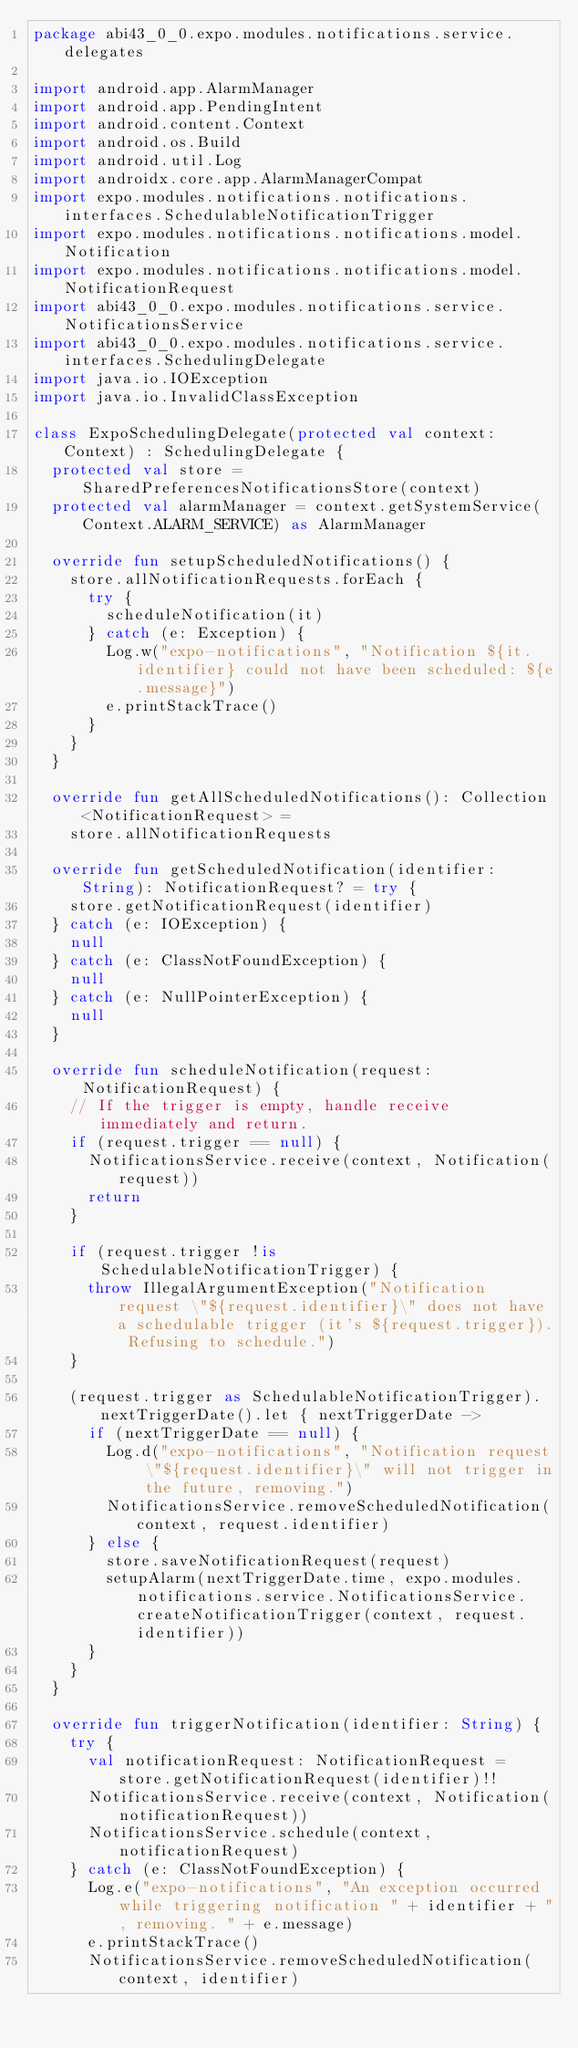<code> <loc_0><loc_0><loc_500><loc_500><_Kotlin_>package abi43_0_0.expo.modules.notifications.service.delegates

import android.app.AlarmManager
import android.app.PendingIntent
import android.content.Context
import android.os.Build
import android.util.Log
import androidx.core.app.AlarmManagerCompat
import expo.modules.notifications.notifications.interfaces.SchedulableNotificationTrigger
import expo.modules.notifications.notifications.model.Notification
import expo.modules.notifications.notifications.model.NotificationRequest
import abi43_0_0.expo.modules.notifications.service.NotificationsService
import abi43_0_0.expo.modules.notifications.service.interfaces.SchedulingDelegate
import java.io.IOException
import java.io.InvalidClassException

class ExpoSchedulingDelegate(protected val context: Context) : SchedulingDelegate {
  protected val store = SharedPreferencesNotificationsStore(context)
  protected val alarmManager = context.getSystemService(Context.ALARM_SERVICE) as AlarmManager

  override fun setupScheduledNotifications() {
    store.allNotificationRequests.forEach {
      try {
        scheduleNotification(it)
      } catch (e: Exception) {
        Log.w("expo-notifications", "Notification ${it.identifier} could not have been scheduled: ${e.message}")
        e.printStackTrace()
      }
    }
  }

  override fun getAllScheduledNotifications(): Collection<NotificationRequest> =
    store.allNotificationRequests

  override fun getScheduledNotification(identifier: String): NotificationRequest? = try {
    store.getNotificationRequest(identifier)
  } catch (e: IOException) {
    null
  } catch (e: ClassNotFoundException) {
    null
  } catch (e: NullPointerException) {
    null
  }

  override fun scheduleNotification(request: NotificationRequest) {
    // If the trigger is empty, handle receive immediately and return.
    if (request.trigger == null) {
      NotificationsService.receive(context, Notification(request))
      return
    }

    if (request.trigger !is SchedulableNotificationTrigger) {
      throw IllegalArgumentException("Notification request \"${request.identifier}\" does not have a schedulable trigger (it's ${request.trigger}). Refusing to schedule.")
    }

    (request.trigger as SchedulableNotificationTrigger).nextTriggerDate().let { nextTriggerDate ->
      if (nextTriggerDate == null) {
        Log.d("expo-notifications", "Notification request \"${request.identifier}\" will not trigger in the future, removing.")
        NotificationsService.removeScheduledNotification(context, request.identifier)
      } else {
        store.saveNotificationRequest(request)
        setupAlarm(nextTriggerDate.time, expo.modules.notifications.service.NotificationsService.createNotificationTrigger(context, request.identifier))
      }
    }
  }

  override fun triggerNotification(identifier: String) {
    try {
      val notificationRequest: NotificationRequest = store.getNotificationRequest(identifier)!!
      NotificationsService.receive(context, Notification(notificationRequest))
      NotificationsService.schedule(context, notificationRequest)
    } catch (e: ClassNotFoundException) {
      Log.e("expo-notifications", "An exception occurred while triggering notification " + identifier + ", removing. " + e.message)
      e.printStackTrace()
      NotificationsService.removeScheduledNotification(context, identifier)</code> 